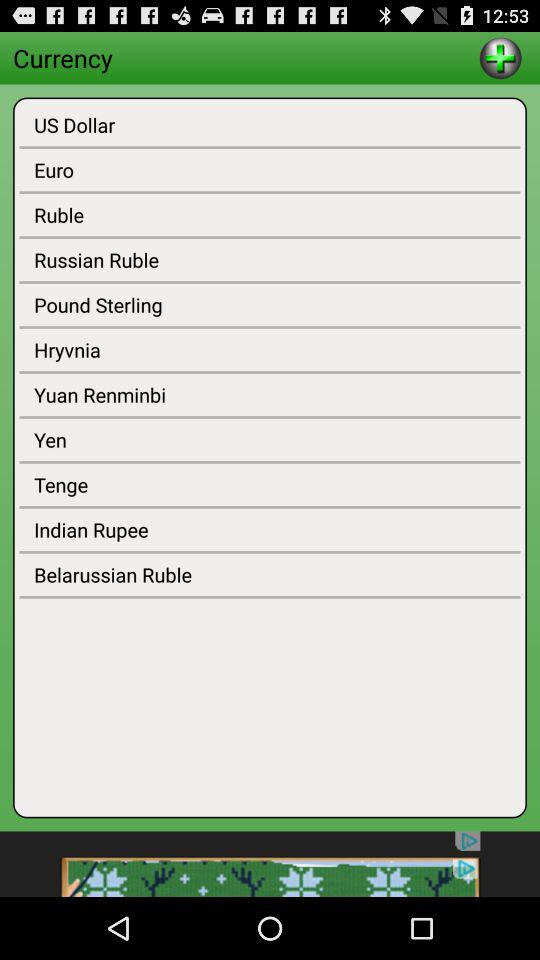What are the available currencies? The available currencies are "US Dollar", "Euro", "Ruble", "Russian Ruble", "Pound Sterling", "Hryvnia", "Yuan Renminbi", "Yen", "Tenge", "Indian Rupee", and "Belarussian Ruble". 